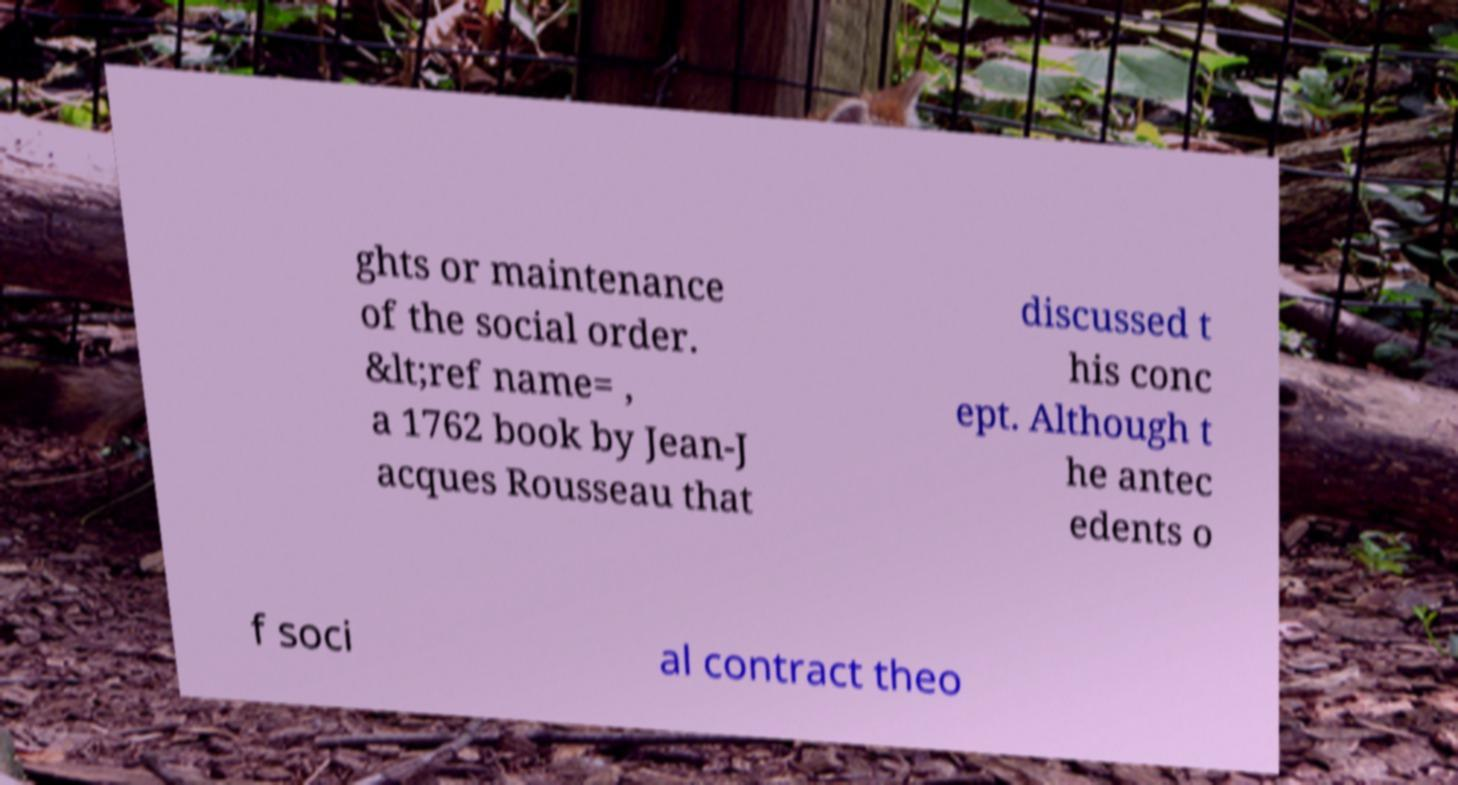There's text embedded in this image that I need extracted. Can you transcribe it verbatim? ghts or maintenance of the social order. &lt;ref name= , a 1762 book by Jean-J acques Rousseau that discussed t his conc ept. Although t he antec edents o f soci al contract theo 